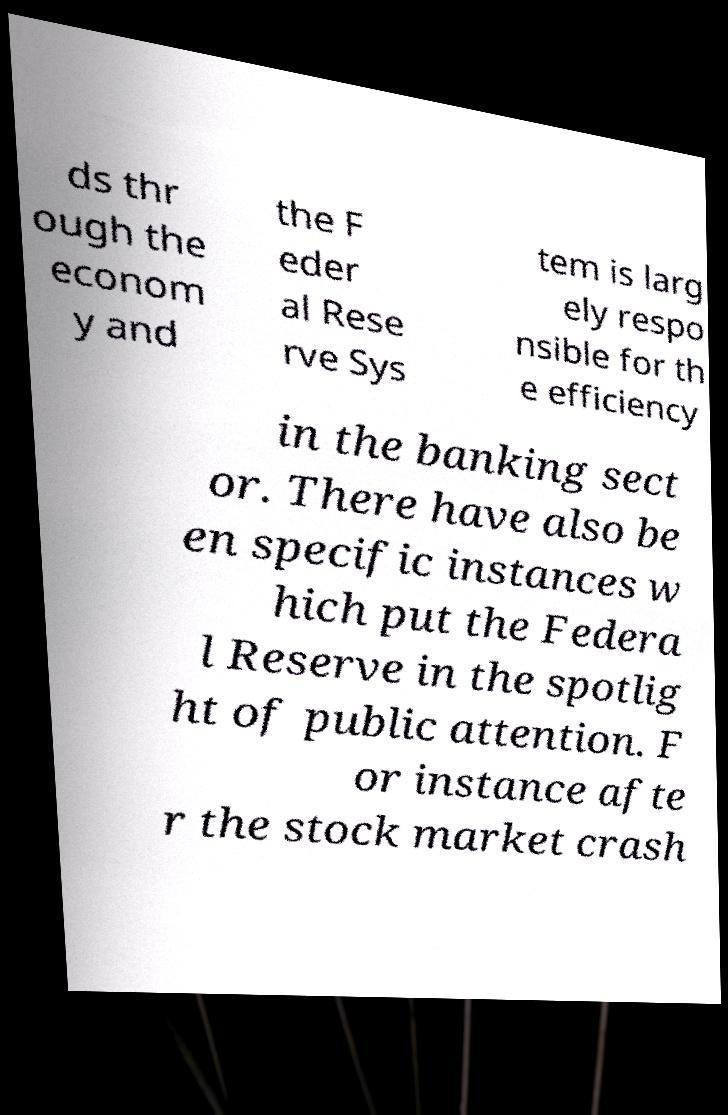Could you assist in decoding the text presented in this image and type it out clearly? ds thr ough the econom y and the F eder al Rese rve Sys tem is larg ely respo nsible for th e efficiency in the banking sect or. There have also be en specific instances w hich put the Federa l Reserve in the spotlig ht of public attention. F or instance afte r the stock market crash 